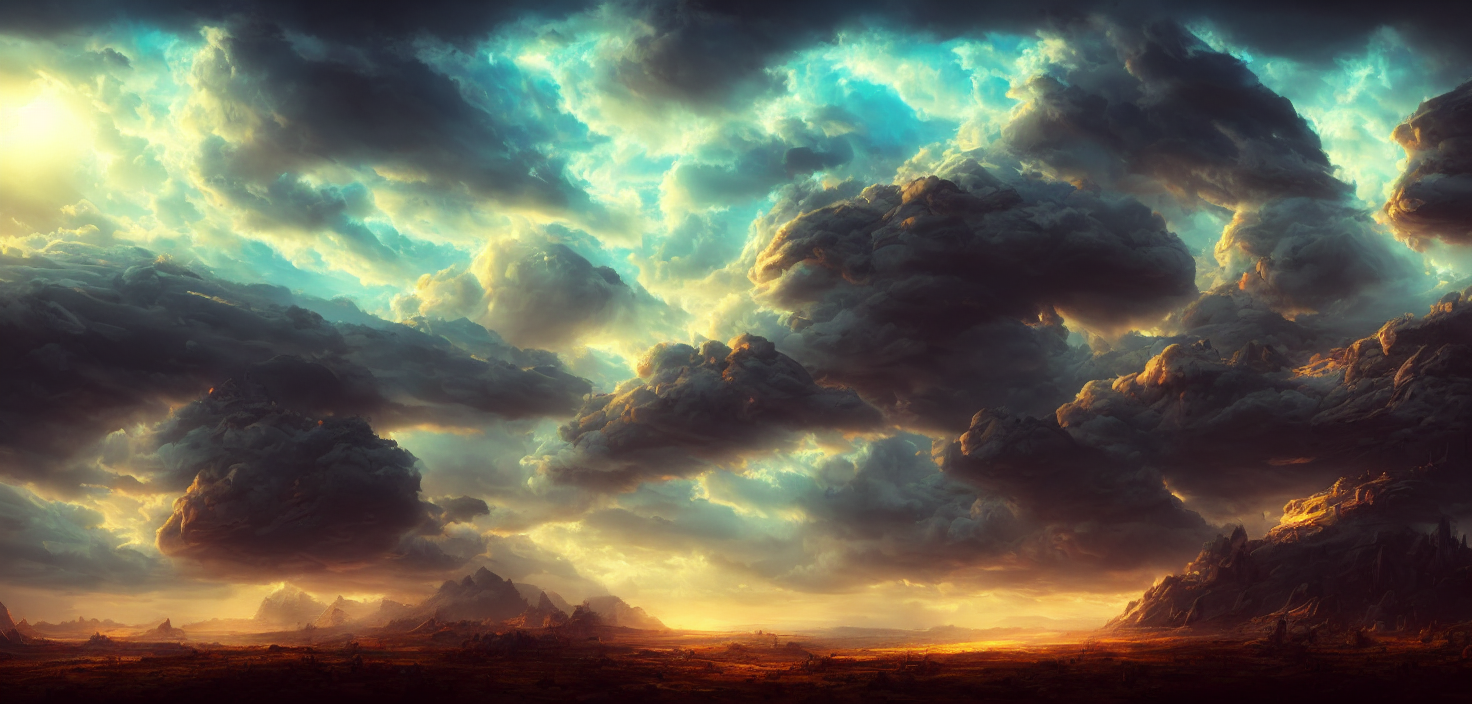Could this image be indicative of a particular weather event? Yes, the towering cumulus clouds and the intense contrast between light and shadow suggest a brewing storm or the aftermath of one, with the sun breaking through the cloud cover, signaling a possible change in weather conditions. 